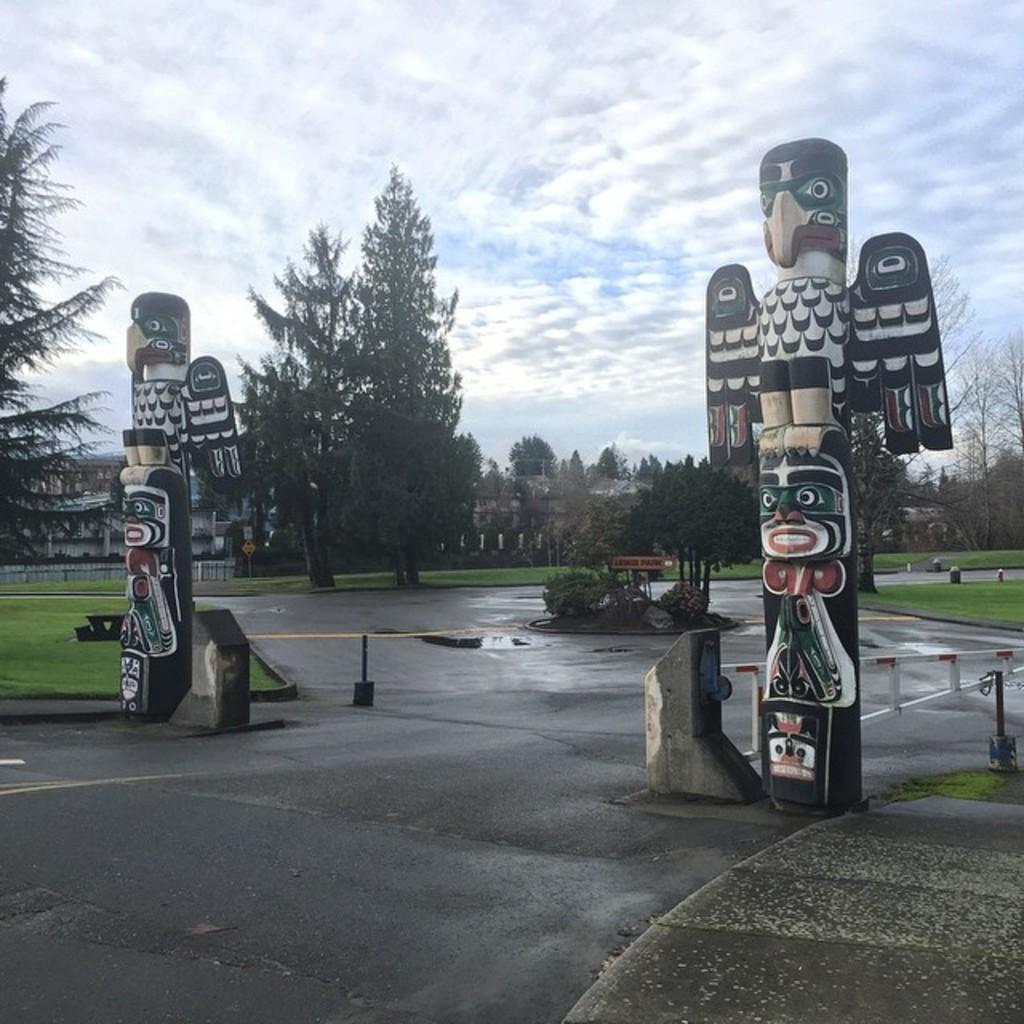What type of pathway is visible in the image? There is a road in the image. What can be seen near the road? There is a name board in the image. What type of vegetation is present in the image? There are trees and grass in the image. What type of structures are visible in the image? There are buildings in the image. What is visible in the background of the image? The sky is visible in the background of the image, and there are clouds in the sky. Can you tell me how many oranges are hanging from the trees in the image? There are no oranges present in the image; the trees are not specified as fruit-bearing trees. What type of insect can be seen flying near the buildings in the image? There is no insect visible in the image, and therefore no such activity can be observed. 